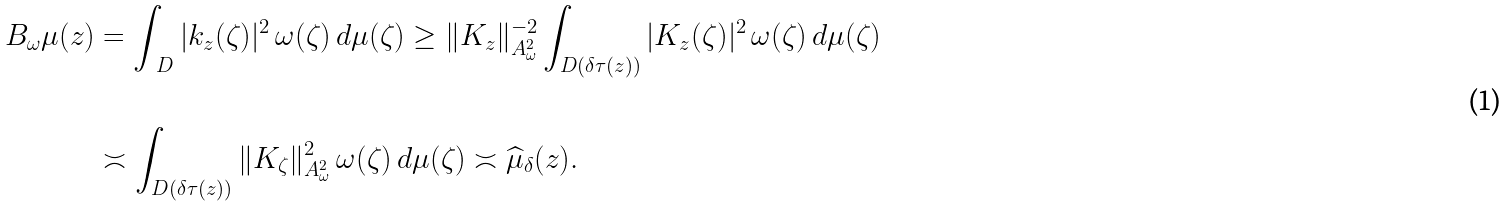<formula> <loc_0><loc_0><loc_500><loc_500>B _ { \omega } \mu ( z ) & = \int _ { \ D } { | k _ { z } ( \zeta ) | ^ { 2 } \, \omega ( \zeta ) \, d \mu ( \zeta ) } \geq \| K _ { z } \| _ { A ^ { 2 } _ { \omega } } ^ { - 2 } \int _ { D ( \delta \tau ( z ) ) } { | K _ { z } ( \zeta ) | ^ { 2 } \, \omega ( \zeta ) \, d \mu ( \zeta ) } \\ \\ & \asymp \int _ { D ( \delta \tau ( z ) ) } { \| K _ { \zeta } \| _ { A ^ { 2 } _ { \omega } } ^ { 2 } \, \omega ( \zeta ) \, d \mu ( \zeta ) } \asymp \widehat { \mu } _ { \delta } ( z ) .</formula> 